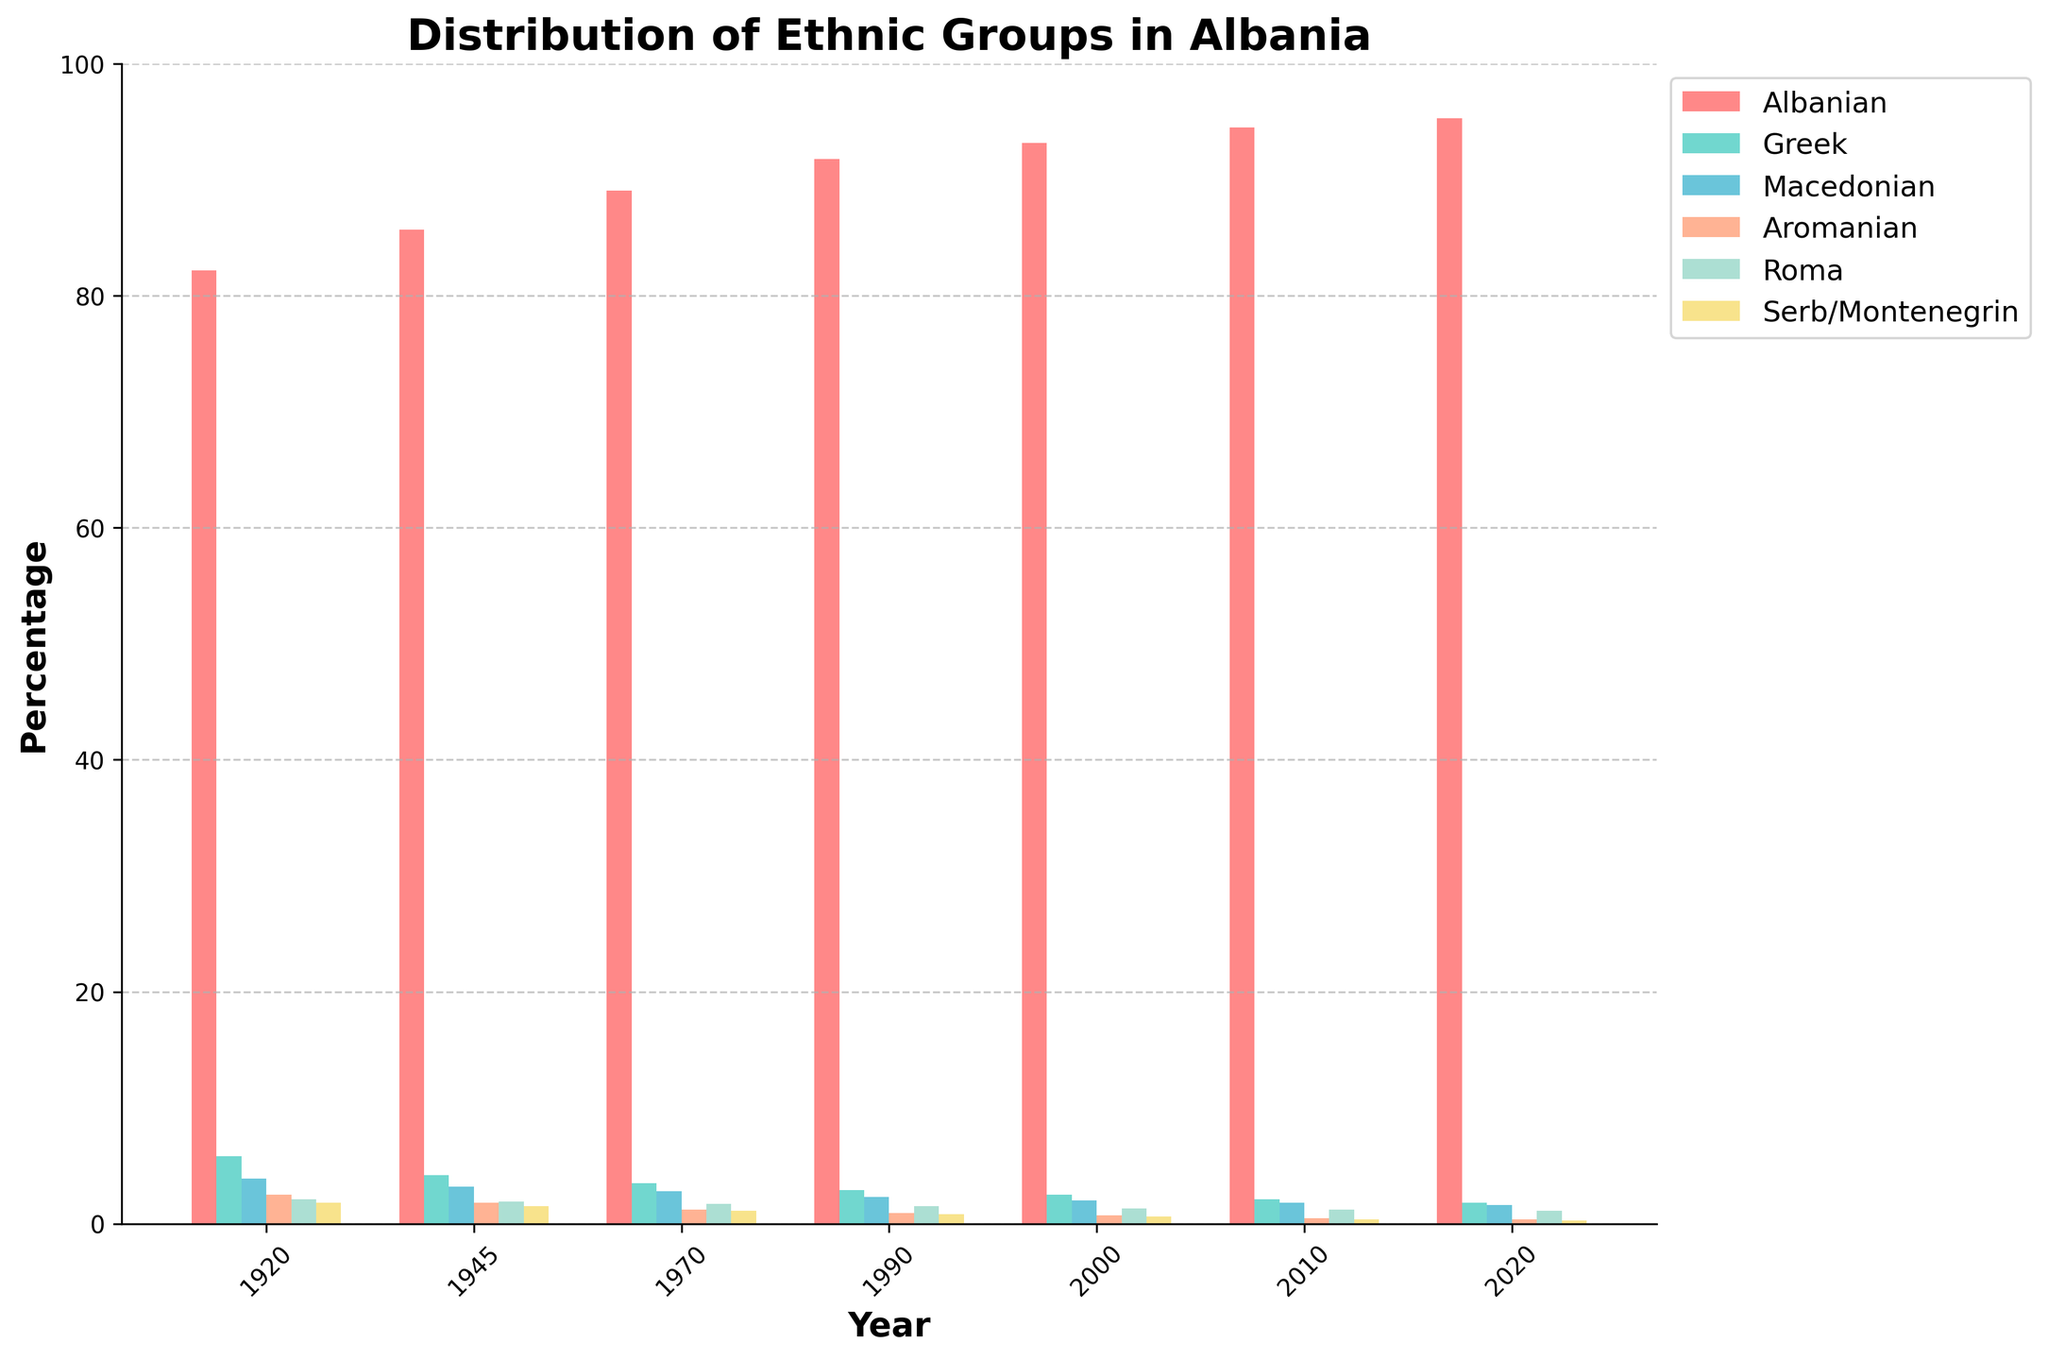What is the overall trend in the percentage of the Albanian ethnic group from 1920 to 2020? The percentage of the Albanian ethnic group shows a consistent increase over time. This can be observed by noting the higher positions of the red bars representing the Albanian group across the years, moving from left to right on the x-axis. The percentage increases from 82.2% in 1920 to 95.3% in 2020.
Answer: Increasing Which group had the largest decline in percentage from 1920 to 2020? To determine this, observe the changes in bar heights for all ethnic groups other than Albanian over time. The Greek ethnic group shows the most significant decline, moving from 5.8% in 1920 to 1.8% in 2020.
Answer: Greek How does the percentage of Macedonians in 1945 compare to that in 2020? Locate the bars for Macedonians in 1945 and 2020. In 1945, Macedonians were at 3.2%, while in 2020, they were at 1.6%. The percentage decreased by 1.6 over the years.
Answer: Decreased In which year did the Aromanian ethnic group have the same percentage as the Serb/Montenegrin group? Look for the year where the heights of the bars representing the Aromanian and Serb/Montenegrin groups are equal. In 2020, both groups have a percentage of 0.4%.
Answer: 2020 Which ethnic group had the smallest representation in 2000, and what percentage does it represent? Compare the heights of the bars for all ethnic groups in the year 2000. The Serb/Montenegrin group had the smallest representation with a percentage of 0.6%.
Answer: Serb/Montenegrin, 0.6% What is the combined percentage of Roma and Aromanian groups in 1970? Identify the percentages for Roma (1.7%) and Aromanian (1.2%) in 1970, then sum them: 1.7% + 1.2% = 2.9%.
Answer: 2.9% What percentage of the total population do the Greek and Macedonian groups represent together in 2010? Identify the percentages for Greek (2.1%) and Macedonian (1.8%) in 2010, then sum them: 2.1% + 1.8% = 3.9%.
Answer: 3.9% Which ethnic group had a steady decline throughout the years shown? By visual inspection, the height of the Greek group's bars consistently decrease from 1920 (5.8%) to 2020 (1.8%).
Answer: Greek 